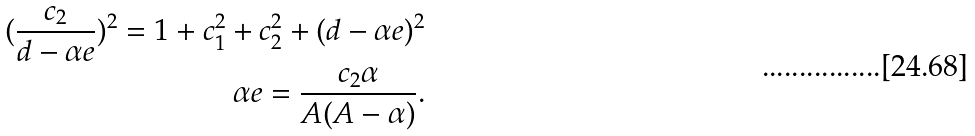Convert formula to latex. <formula><loc_0><loc_0><loc_500><loc_500>( \frac { c _ { 2 } } { d - \alpha e } ) ^ { 2 } = 1 + c _ { 1 } ^ { 2 } + c _ { 2 } ^ { 2 } + ( d - \alpha e ) ^ { 2 } \\ \alpha e = \frac { c _ { 2 } \alpha } { A ( A - \alpha ) } .</formula> 